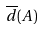Convert formula to latex. <formula><loc_0><loc_0><loc_500><loc_500>\overline { d } ( A )</formula> 